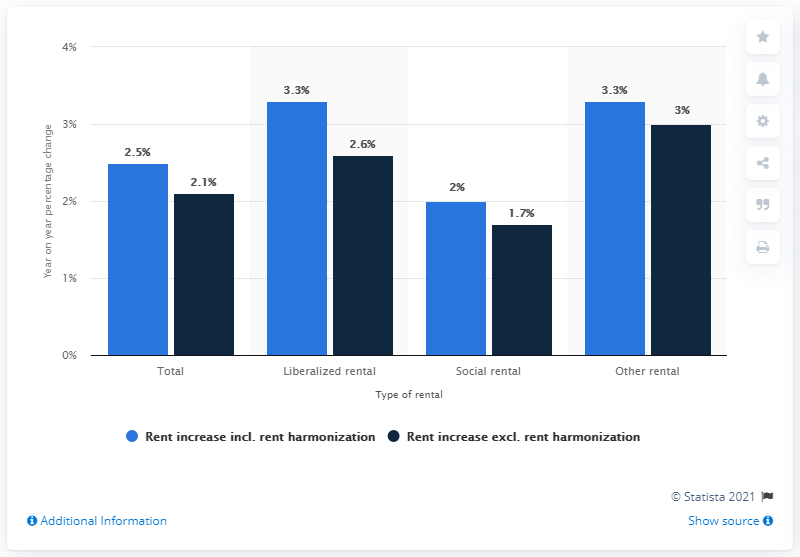Highlight a few significant elements in this photo. The average rent in the Netherlands increased by 2.5% in 2019 compared to the previous year. The total percentage change in rents in the Netherlands in 2019, excluding social rental, was 3.7%. The percentage change in rents for social rental was not provided. 